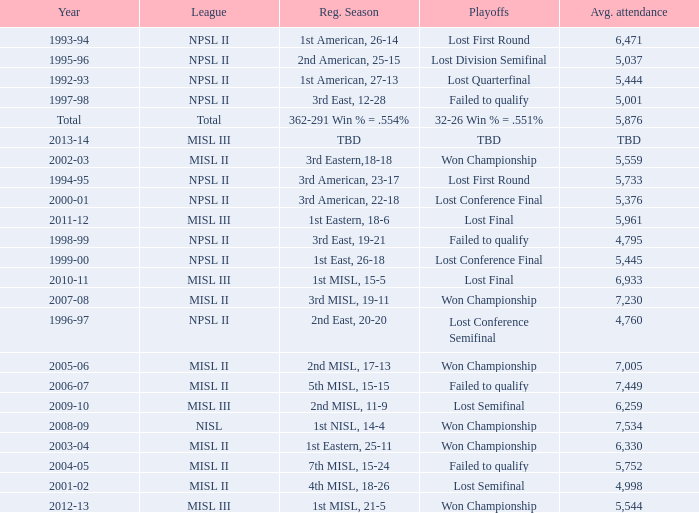When was the year that had an average attendance of 5,445? 1999-00. 